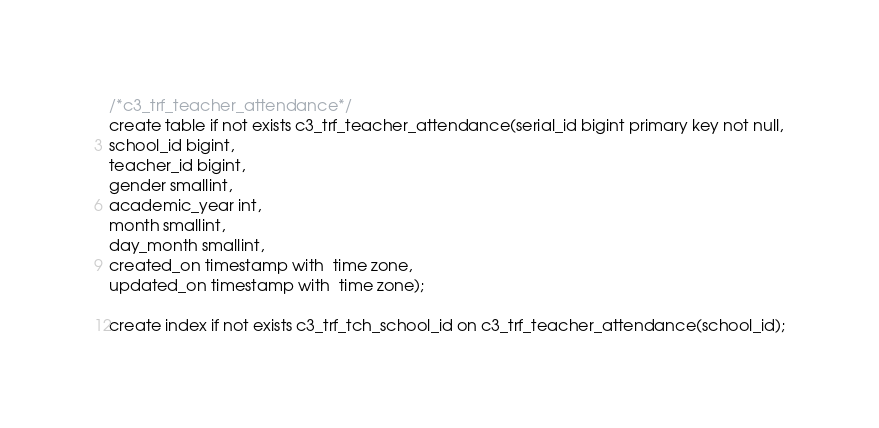Convert code to text. <code><loc_0><loc_0><loc_500><loc_500><_SQL_>
/*c3_trf_teacher_attendance*/
create table if not exists c3_trf_teacher_attendance(serial_id bigint primary key not null,
school_id bigint,
teacher_id bigint,
gender smallint,
academic_year int,
month smallint,
day_month smallint,
created_on timestamp with  time zone,
updated_on timestamp with  time zone);

create index if not exists c3_trf_tch_school_id on c3_trf_teacher_attendance(school_id);
</code> 